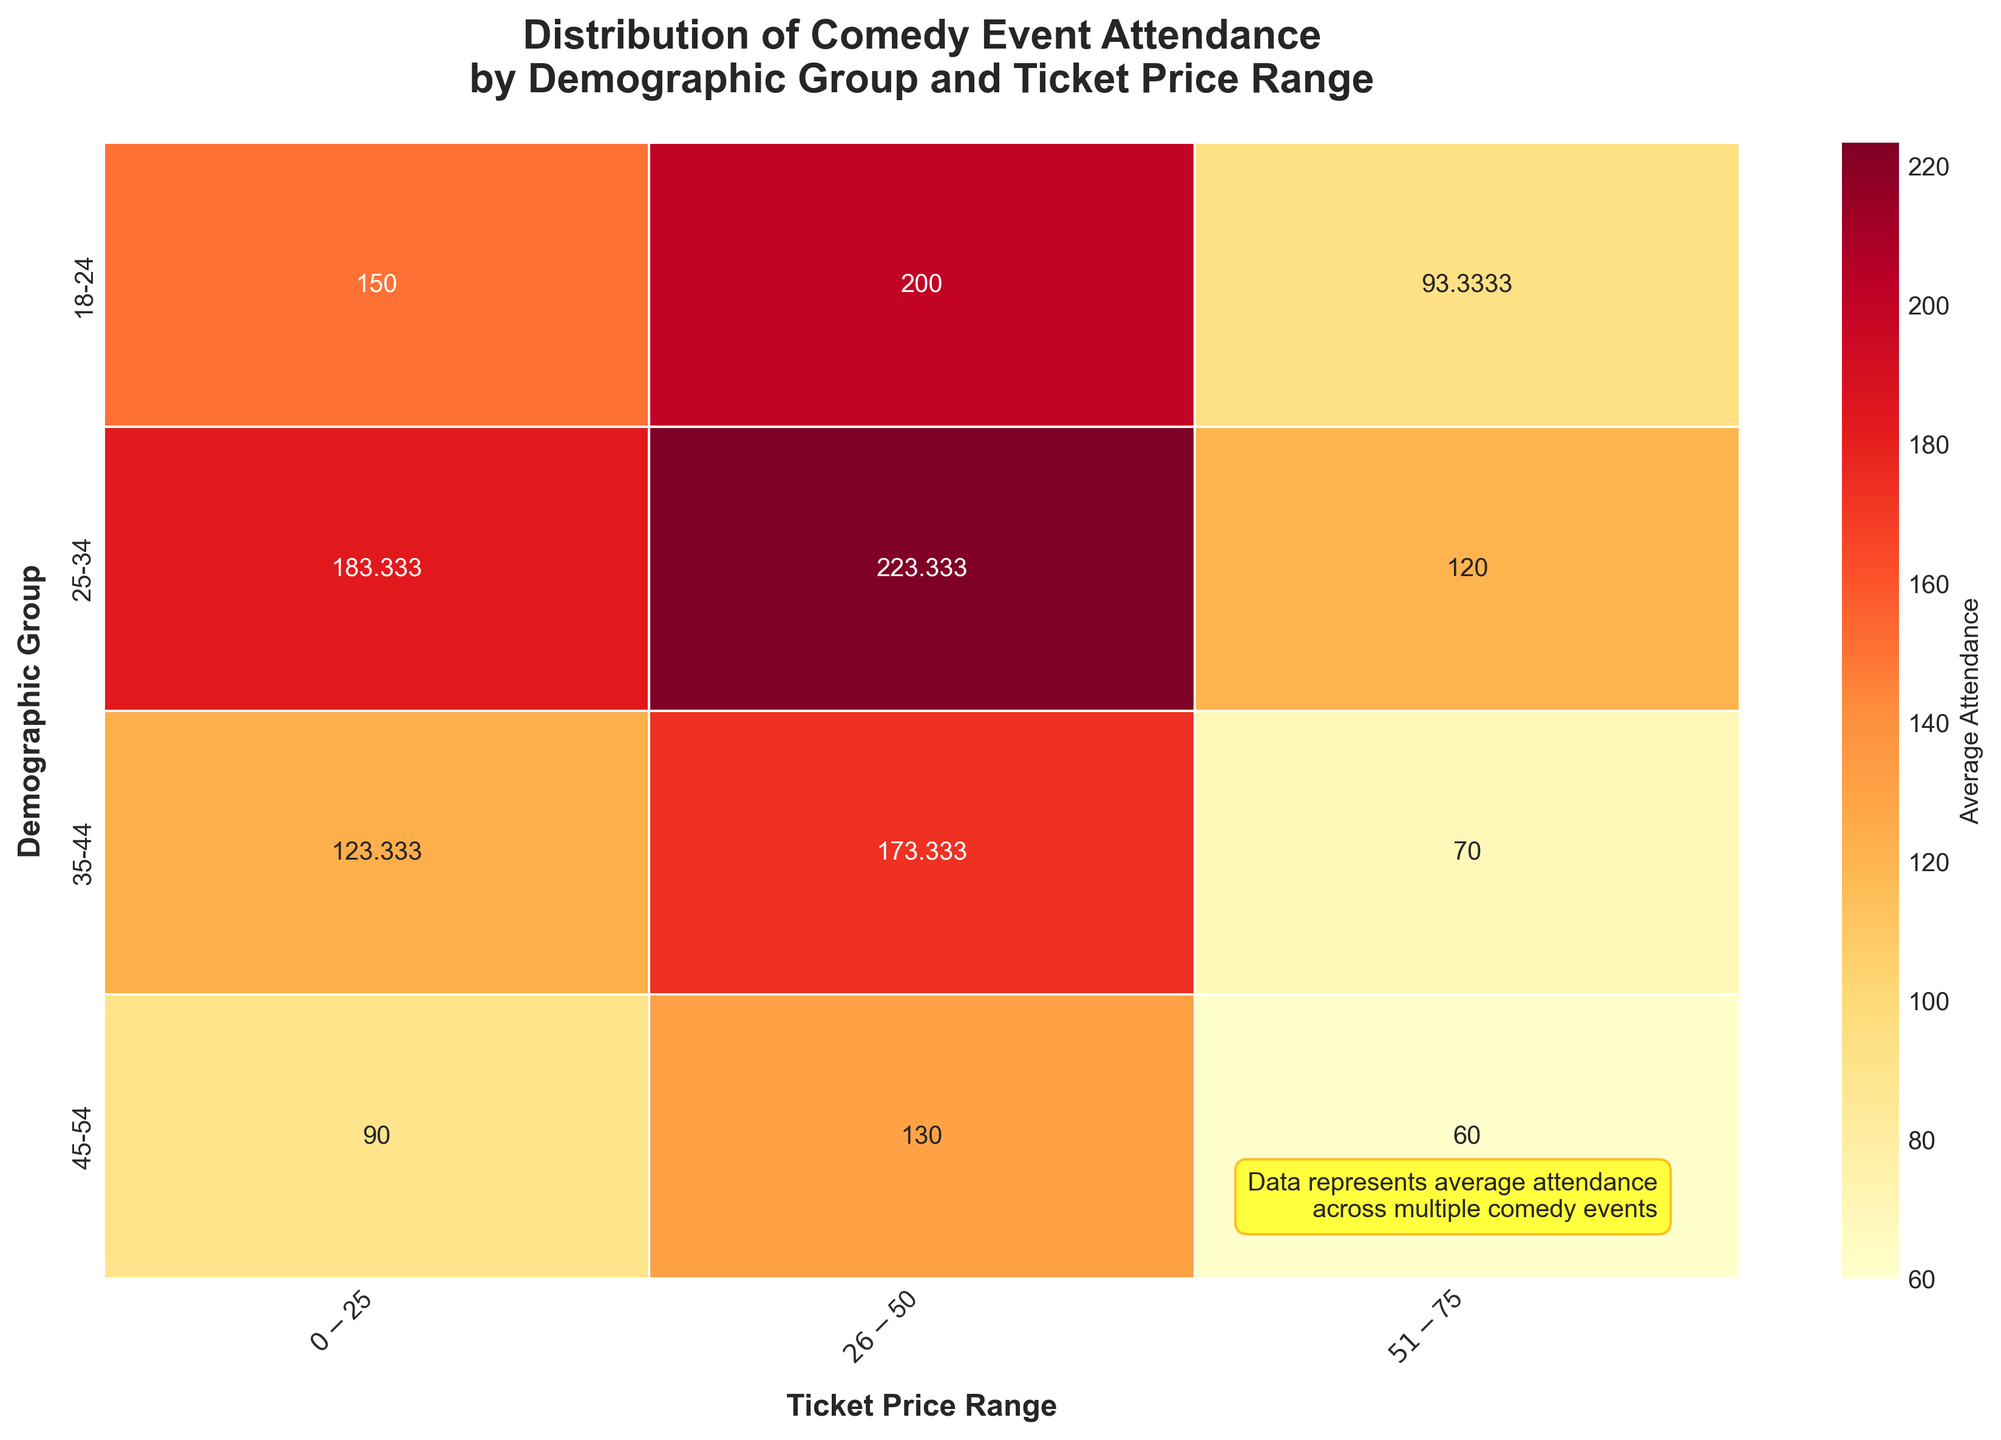What is the title of the heatmap? The title is usually displayed at the top of the figure, so you can locate it easily. It can help understand the context of the data represented by the heatmap.
Answer: Distribution of Comedy Event Attendance by Demographic Group and Ticket Price Range What demographic group has the highest average attendance for ticket prices ranging $26-$50? Check the intersecting cell of the demographic group row and the $26-$50 column. The cell with the highest value indicates the highest average attendance.
Answer: 25-34 Which ticket price range sees the least attendance from the 45-54 age group? Look at the row for the 45-54 age group and identify the smallest value among the different ticket price range columns.
Answer: $51-$75 Is the average attendance higher for the $0-$25 or the $51-$75 ticket price range for the 18-24 demographic? Compare the values at the intersection of the 18-24 row with the $0-$25 and $51-$75 columns. Check which value is higher.
Answer: $0-$25 How does the average attendance for the $26-$50 and $51-$75 ticket price ranges compare across all demographic groups? For each demographic group, compare the values for $26-$50 and $51-$75. Note if the attendance is higher, lower, or equal in each pair. Summarize the overall trend.
Answer: Generally higher for $26-$50 across all groups Which demographic group has the most balanced attendance across all ticket price ranges? For each demographic group, assess the variance in attendance values across the three ticket price ranges. The group with the smallest variance is the most balanced.
Answer: 25-34 What is the average attendance across all demographic groups for the $0-$25 ticket price range? Sum the values in the $0-$25 column for all rows and divide by the number of demographic groups.
Answer: (150+180+120+90+140+170+110+80+160+200+140+100) / 12 = 137.5 Which demographic group sees the largest drop in attendance when moving from the $0-$25 to the $51-$75 ticket price range? Calculate the difference in attendance between $0-$25 and $51-$75 for each demographic group, identify the group with the largest negative difference.
Answer: 45-54 (100 to 65, a drop of 35) Is there a noticeable trend in attendance across different ticket price ranges for the 35-44 demographic? Examine the values for the 35-44 row across different ticket price ranges and identify if there is an increasing or decreasing trend.
Answer: Decreasing trend 